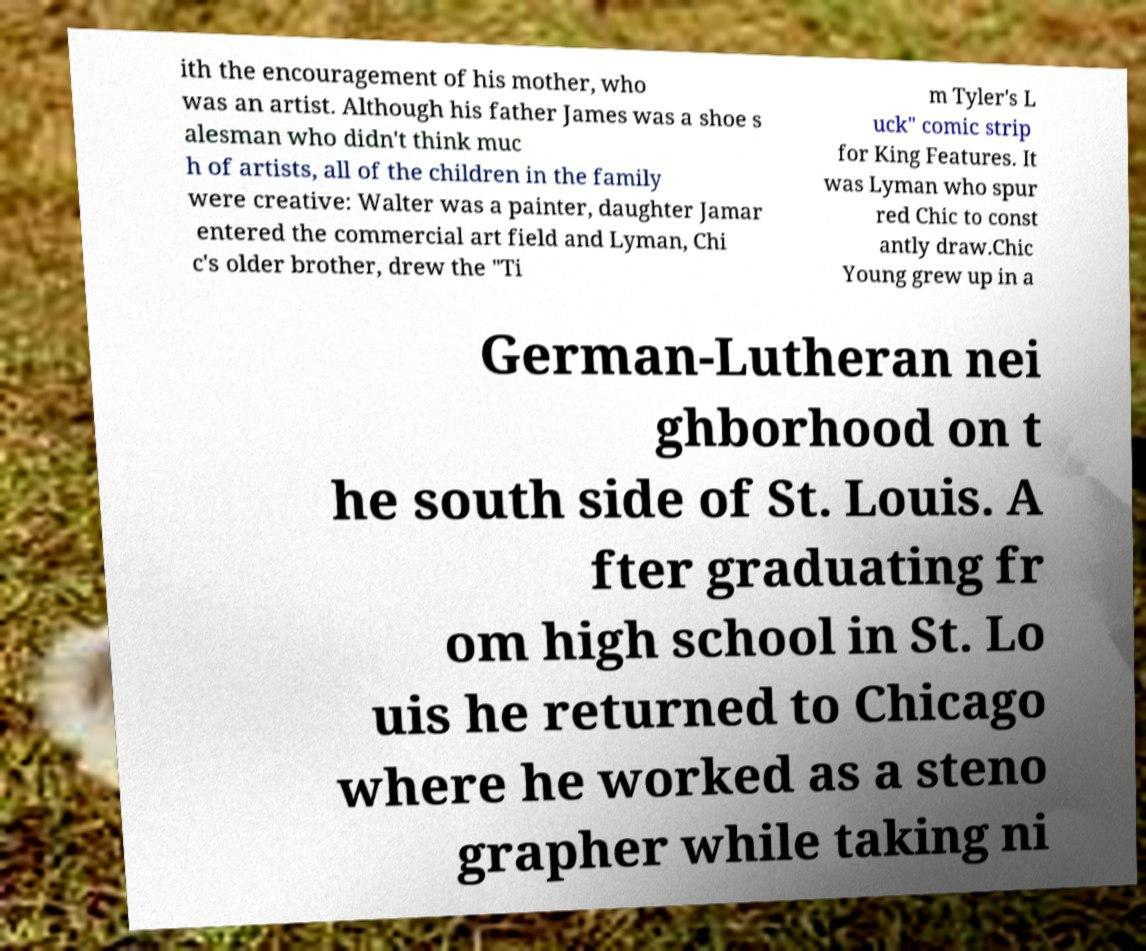I need the written content from this picture converted into text. Can you do that? ith the encouragement of his mother, who was an artist. Although his father James was a shoe s alesman who didn't think muc h of artists, all of the children in the family were creative: Walter was a painter, daughter Jamar entered the commercial art field and Lyman, Chi c's older brother, drew the "Ti m Tyler's L uck" comic strip for King Features. It was Lyman who spur red Chic to const antly draw.Chic Young grew up in a German-Lutheran nei ghborhood on t he south side of St. Louis. A fter graduating fr om high school in St. Lo uis he returned to Chicago where he worked as a steno grapher while taking ni 